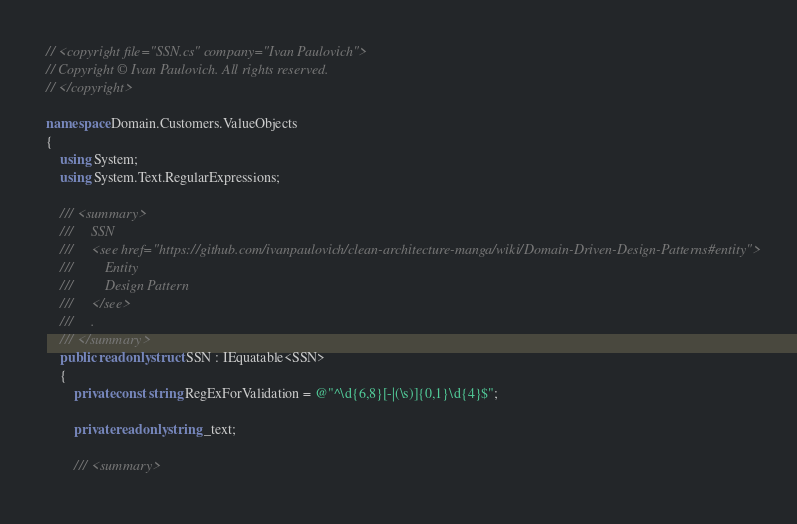<code> <loc_0><loc_0><loc_500><loc_500><_C#_>// <copyright file="SSN.cs" company="Ivan Paulovich">
// Copyright © Ivan Paulovich. All rights reserved.
// </copyright>

namespace Domain.Customers.ValueObjects
{
    using System;
    using System.Text.RegularExpressions;

    /// <summary>
    ///     SSN
    ///     <see href="https://github.com/ivanpaulovich/clean-architecture-manga/wiki/Domain-Driven-Design-Patterns#entity">
    ///         Entity
    ///         Design Pattern
    ///     </see>
    ///     .
    /// </summary>
    public readonly struct SSN : IEquatable<SSN>
    {
        private const string RegExForValidation = @"^\d{6,8}[-|(\s)]{0,1}\d{4}$";

        private readonly string _text;

        /// <summary></code> 